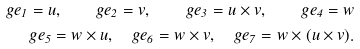<formula> <loc_0><loc_0><loc_500><loc_500>g e _ { 1 } = u , \quad g e _ { 2 } = v , \quad g e _ { 3 } = u \times v , \quad g e _ { 4 } = w \\ g e _ { 5 } = w \times u , \quad g e _ { 6 } = w \times v , \quad g e _ { 7 } = w \times ( u \times v ) .</formula> 